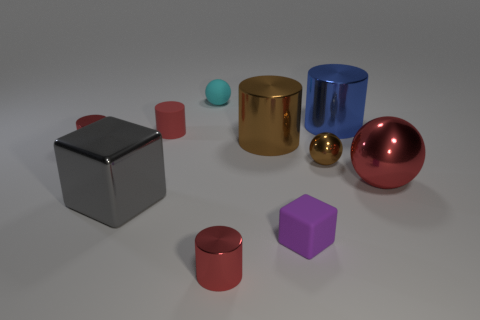What are the different materials represented in this image? In this image, there appear to be objects made of various materials including metal, as seen in the reflective surfaces of the cylinder and the small ball; plastic or matte surfaces, as suggested by the cube and the purple square; and possibly rubber or a similar matte material for the small red cylinder and blue sphere, given their less reflective appearances. 